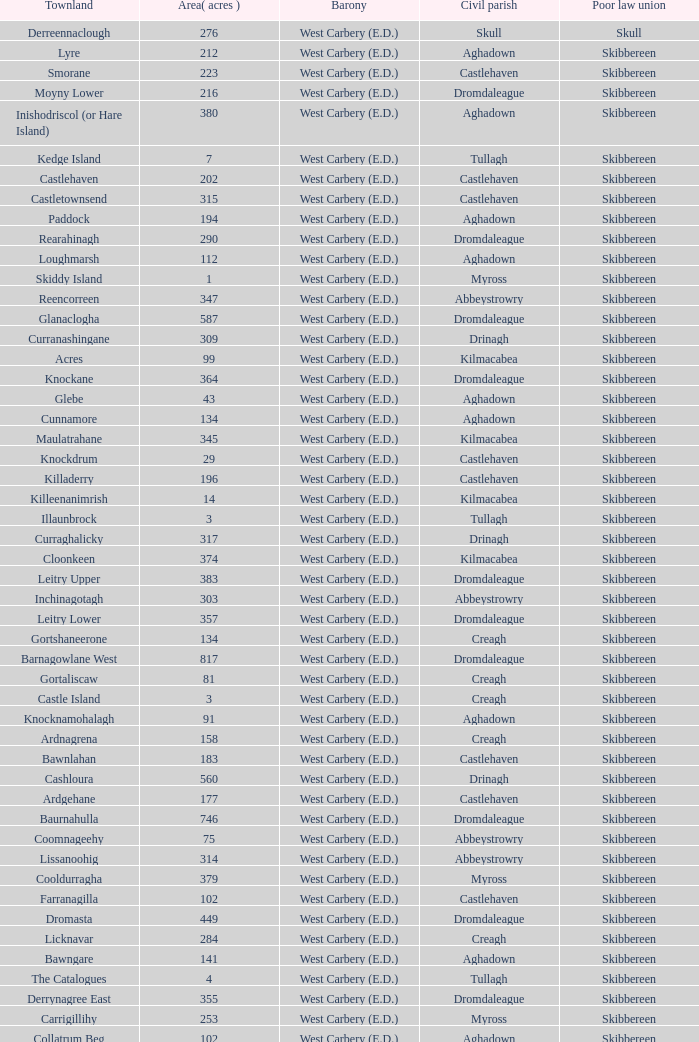What is the greatest area when the Poor Law Union is Skibbereen and the Civil Parish is Tullagh? 796.0. 